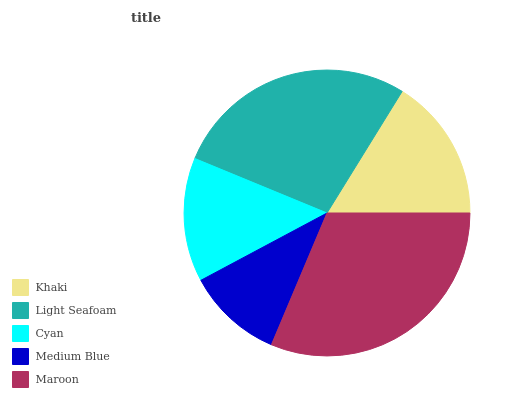Is Medium Blue the minimum?
Answer yes or no. Yes. Is Maroon the maximum?
Answer yes or no. Yes. Is Light Seafoam the minimum?
Answer yes or no. No. Is Light Seafoam the maximum?
Answer yes or no. No. Is Light Seafoam greater than Khaki?
Answer yes or no. Yes. Is Khaki less than Light Seafoam?
Answer yes or no. Yes. Is Khaki greater than Light Seafoam?
Answer yes or no. No. Is Light Seafoam less than Khaki?
Answer yes or no. No. Is Khaki the high median?
Answer yes or no. Yes. Is Khaki the low median?
Answer yes or no. Yes. Is Light Seafoam the high median?
Answer yes or no. No. Is Light Seafoam the low median?
Answer yes or no. No. 